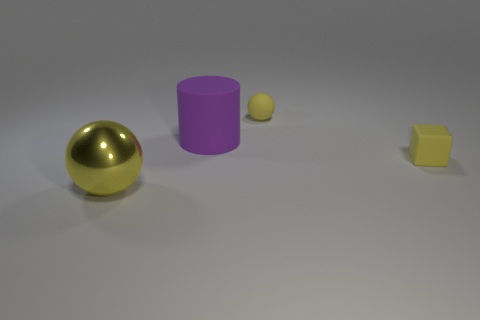Add 4 rubber spheres. How many objects exist? 8 Subtract all cylinders. How many objects are left? 3 Add 4 large purple matte objects. How many large purple matte objects are left? 5 Add 1 big purple cylinders. How many big purple cylinders exist? 2 Subtract 1 yellow spheres. How many objects are left? 3 Subtract all purple rubber things. Subtract all matte cylinders. How many objects are left? 2 